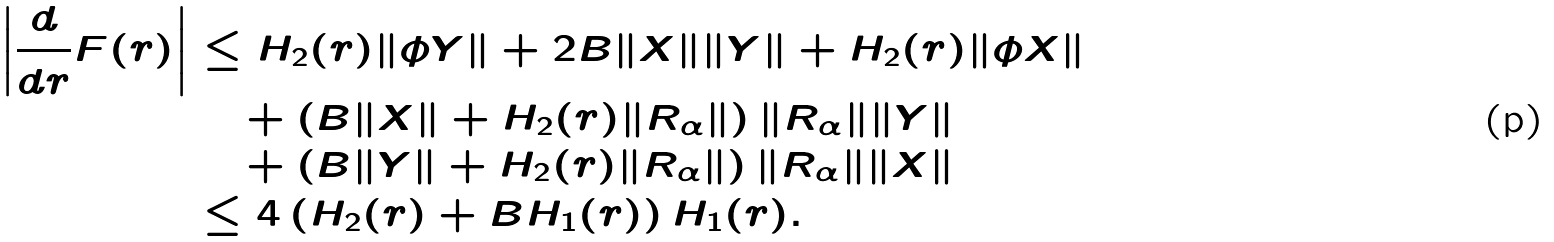<formula> <loc_0><loc_0><loc_500><loc_500>\left | \frac { d } { d r } F ( r ) \right | & \leq H _ { 2 } ( r ) \| \phi Y \| + 2 B \| X \| \| Y \| + H _ { 2 } ( r ) \| \phi X \| \\ & \quad + \left ( B \| X \| + H _ { 2 } ( r ) \| R _ { \alpha } \| \right ) \| R _ { \alpha } \| \| Y \| \\ & \quad + \left ( B \| Y \| + H _ { 2 } ( r ) \| R _ { \alpha } \| \right ) \| R _ { \alpha } \| \| X \| \\ & \leq 4 \left ( H _ { 2 } ( r ) + B H _ { 1 } ( r ) \right ) H _ { 1 } ( r ) .</formula> 